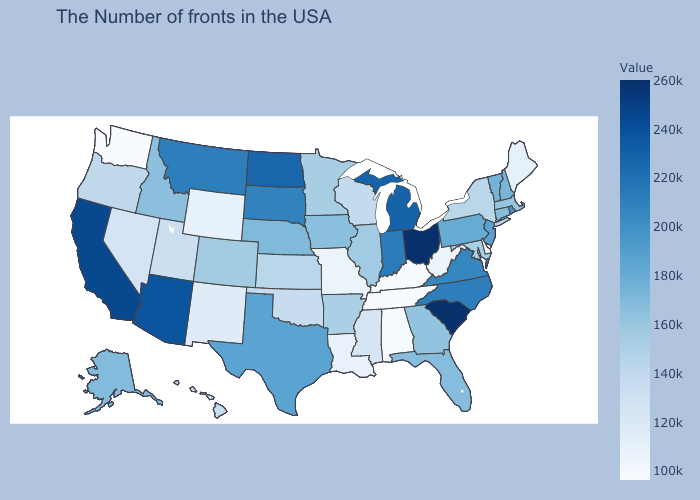Is the legend a continuous bar?
Answer briefly. Yes. Is the legend a continuous bar?
Give a very brief answer. Yes. Does Delaware have the lowest value in the USA?
Concise answer only. Yes. Which states hav the highest value in the South?
Write a very short answer. South Carolina. Does Michigan have a lower value than South Carolina?
Keep it brief. Yes. 